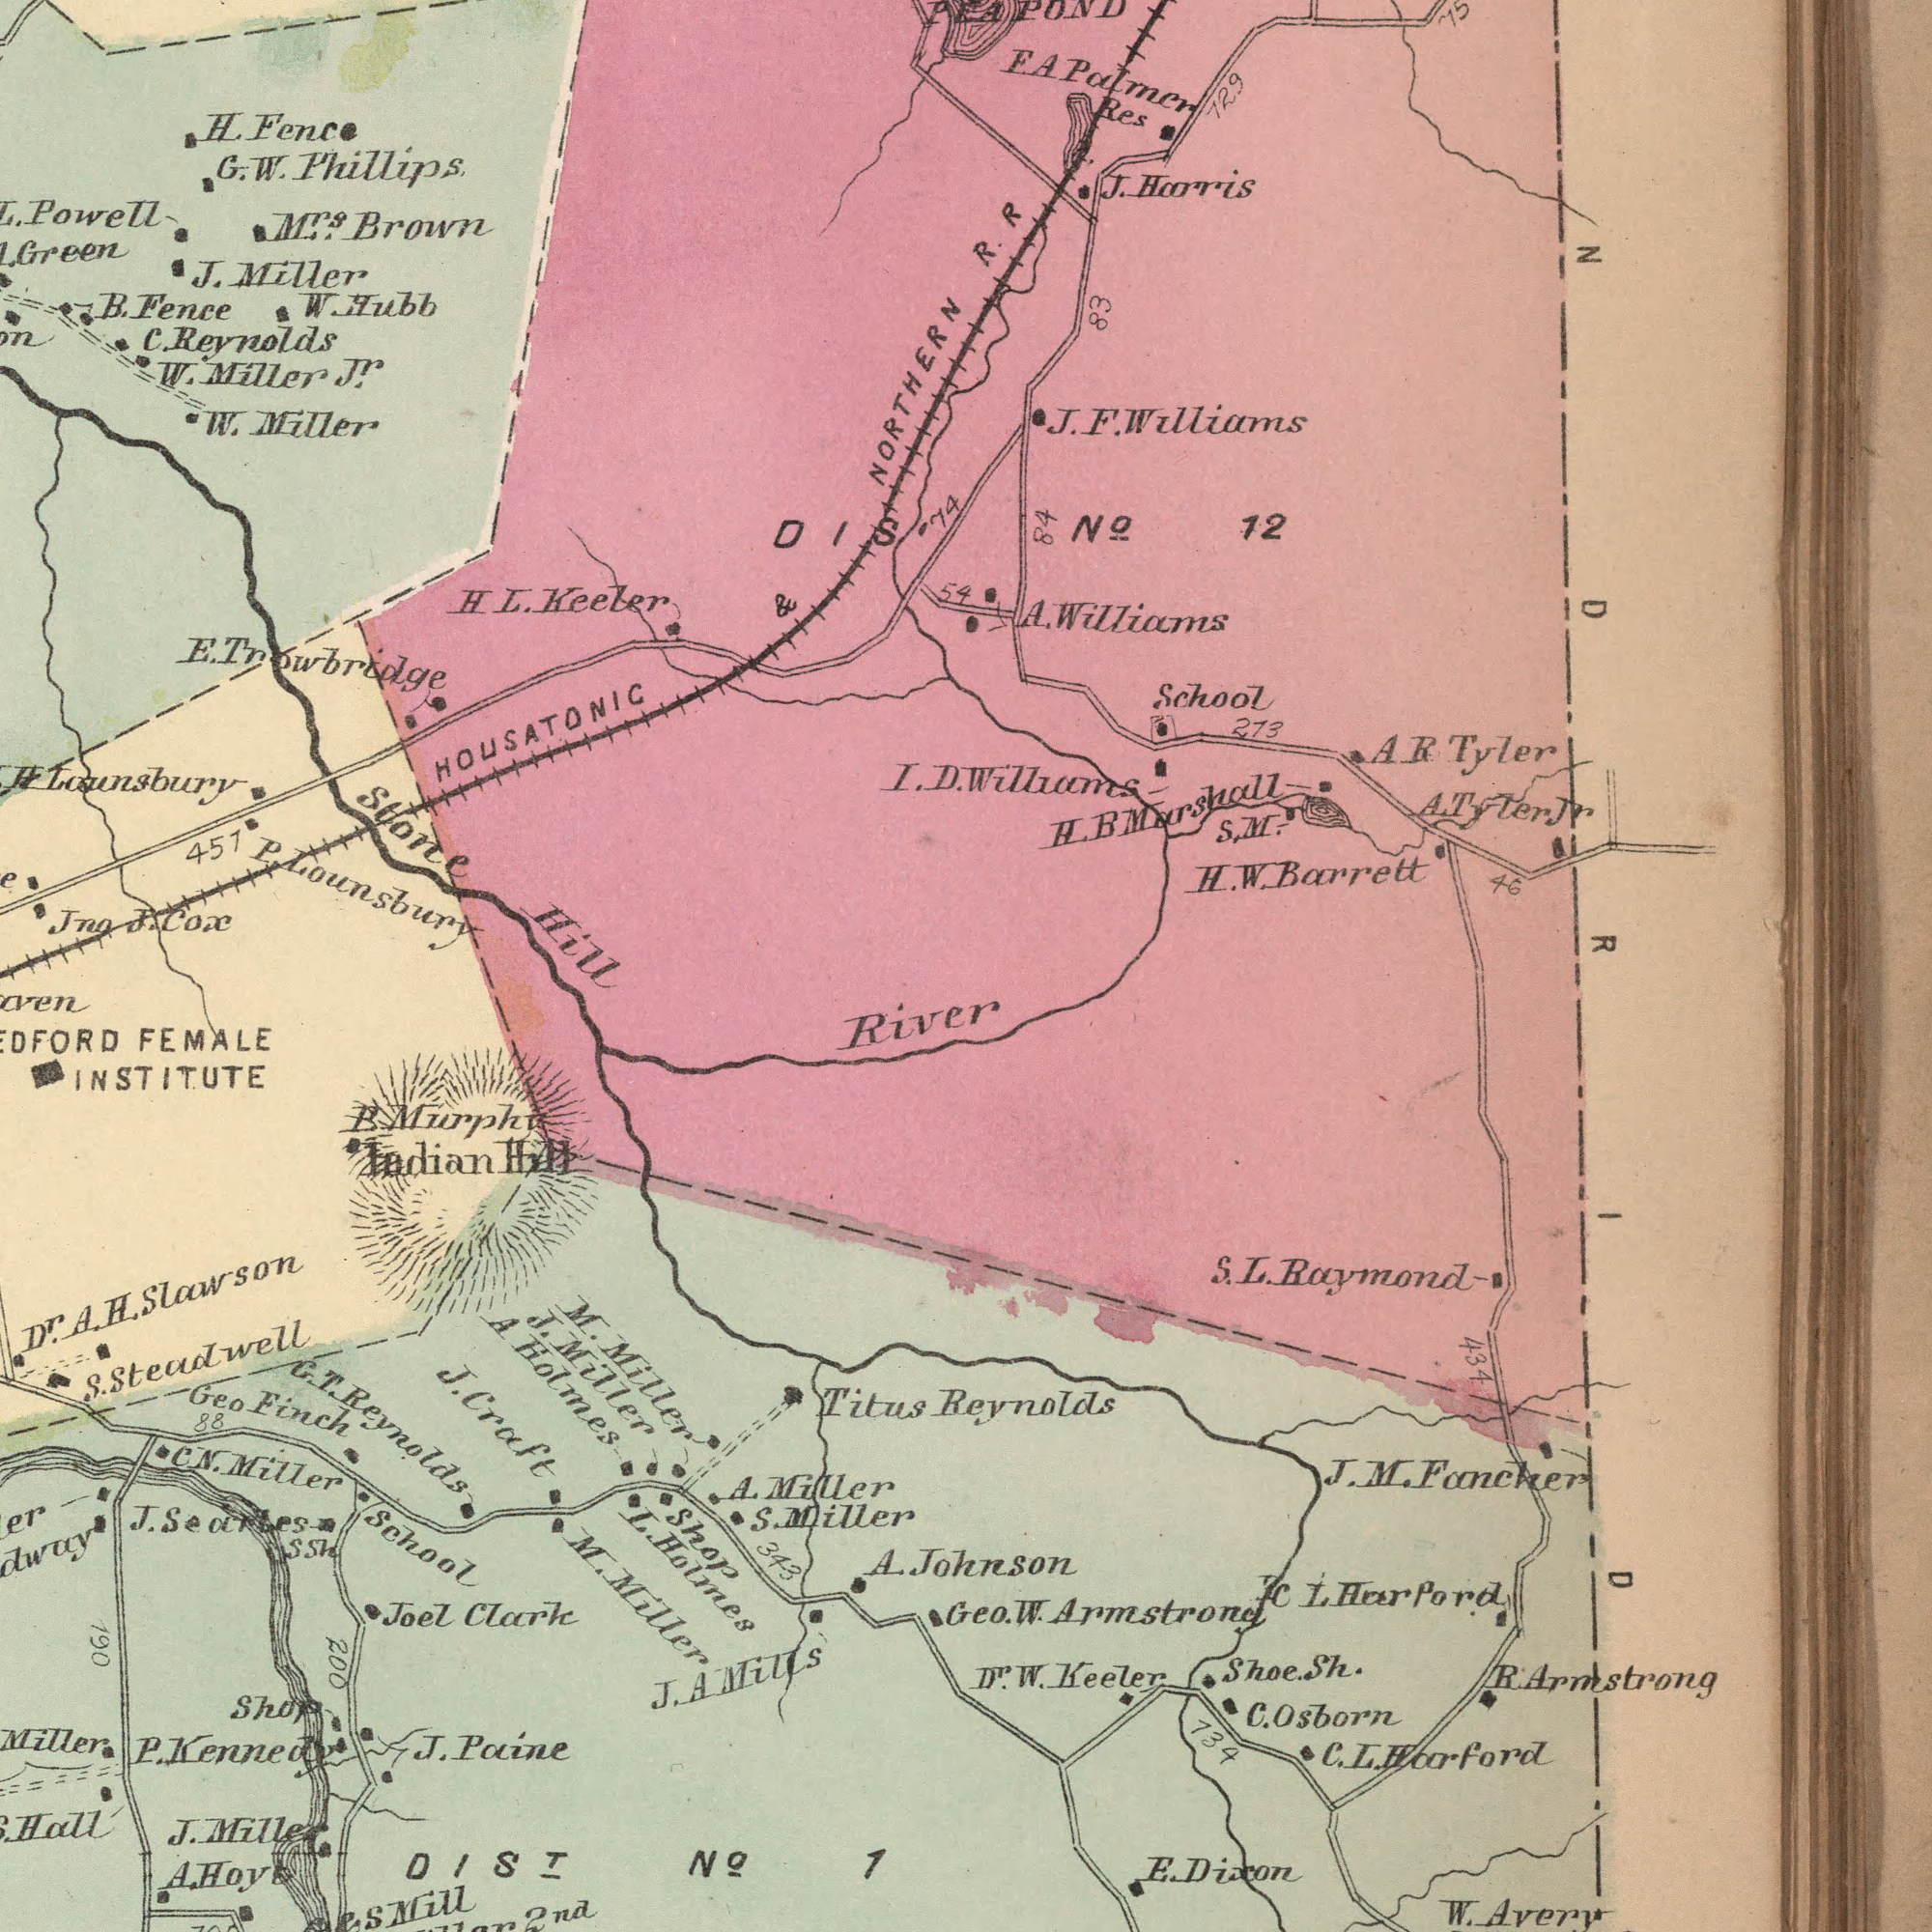What text is shown in the bottom-right quadrant? River Titus Reynolds 1 A. Johnson W. Avery E. Dixon Shoe. Sh. J. M. Fancher C L. Harpord C. L. Harford 734 Geo. W. Armstrone D<sup>r</sup>. W. Keeler R. Armstrong S. L. Raymond C. Osborn 434 What text appears in the top-left area of the image? Stone Hil Powell C. Reynolds P. Lounsbury Green W. Miller J<sup>r</sup>. J. Miller B. Fence H. Fence M<sup>rs</sup>. Brown G. w. Phillips 451 HOUSATONIC & H. L. Keeler W. Miller W. Hubb H Lounsbury DIS E. Trowbridge J. Cox Jna What text can you see in the top-right section? NORTHERN R. R NoÍ 12 54 PEA POND 74 H. W. Barrett 46 A R Tyler School E. A Palmer Res A. Williams J. Harris 84 273 H. B Marshall I. D. Williams J. F. Williams 729 83 A. Tyler J<sup>r</sup> S. M. What text is visible in the lower-left corner? L. Holmes School FEMALE INSTITUTE Geo Finch Miller C N. Miller J. Miller J. Craft DISá¹® NoÍ A Holmes Joel Clark 2nd Hall B. Murphy D<sup>r</sup>. A. H. Slawson J. Miller Indian Hill S. Steadwell 343 Shop J. Paine A. Miller ssh 200 88 M. Miller J. G. T. Reynolds Shop M. Miller S. Miller J. A Mills 190 A. Hoy P. Kennedy Mill 